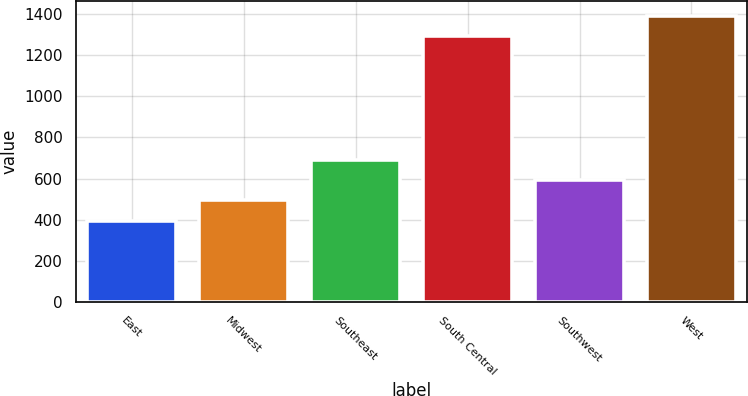<chart> <loc_0><loc_0><loc_500><loc_500><bar_chart><fcel>East<fcel>Midwest<fcel>Southeast<fcel>South Central<fcel>Southwest<fcel>West<nl><fcel>396.3<fcel>493.98<fcel>689.34<fcel>1293.3<fcel>591.66<fcel>1390.98<nl></chart> 